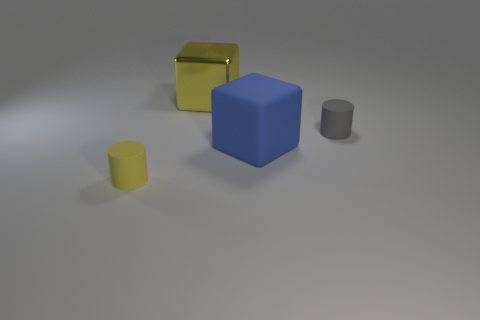Imagine if these objects were part of a larger scene, what could that look like? Envisioning a larger context, these objects might be elements in an educational setting, perhaps as teaching aids for geometry or in a child's play area designed to explore shapes and colors. Alternatively, they could be part of a minimalist art installation. 